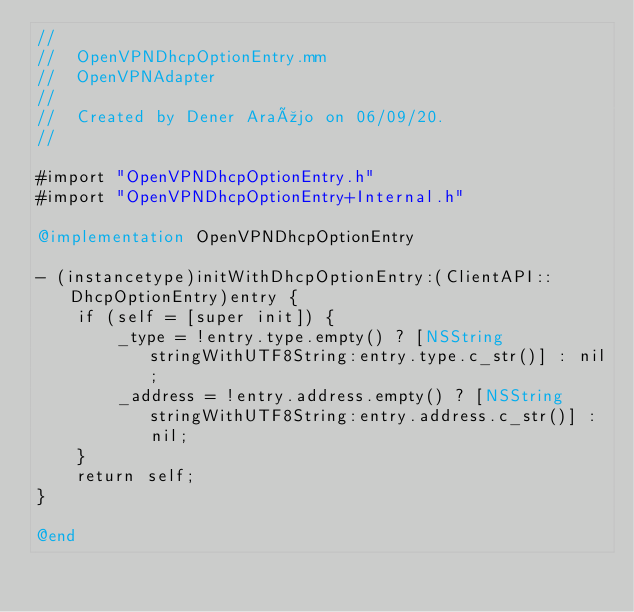Convert code to text. <code><loc_0><loc_0><loc_500><loc_500><_ObjectiveC_>//
//  OpenVPNDhcpOptionEntry.mm
//  OpenVPNAdapter
//
//  Created by Dener Araújo on 06/09/20.
//

#import "OpenVPNDhcpOptionEntry.h"
#import "OpenVPNDhcpOptionEntry+Internal.h"

@implementation OpenVPNDhcpOptionEntry

- (instancetype)initWithDhcpOptionEntry:(ClientAPI::DhcpOptionEntry)entry {
    if (self = [super init]) {
        _type = !entry.type.empty() ? [NSString stringWithUTF8String:entry.type.c_str()] : nil;
        _address = !entry.address.empty() ? [NSString stringWithUTF8String:entry.address.c_str()] : nil;
    }
    return self;
}

@end
</code> 